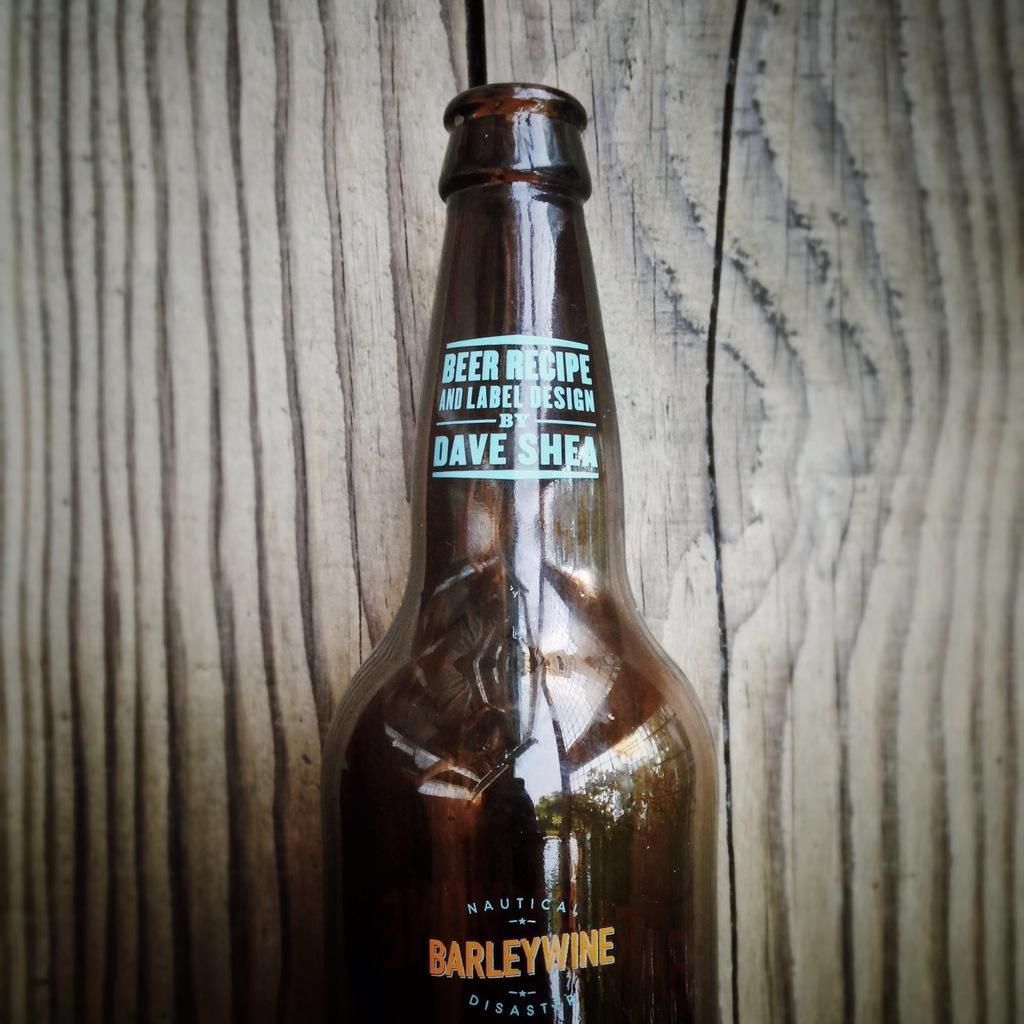<image>
Summarize the visual content of the image. A bottle of BarleyWine from Nautica against a wood backdrop. 